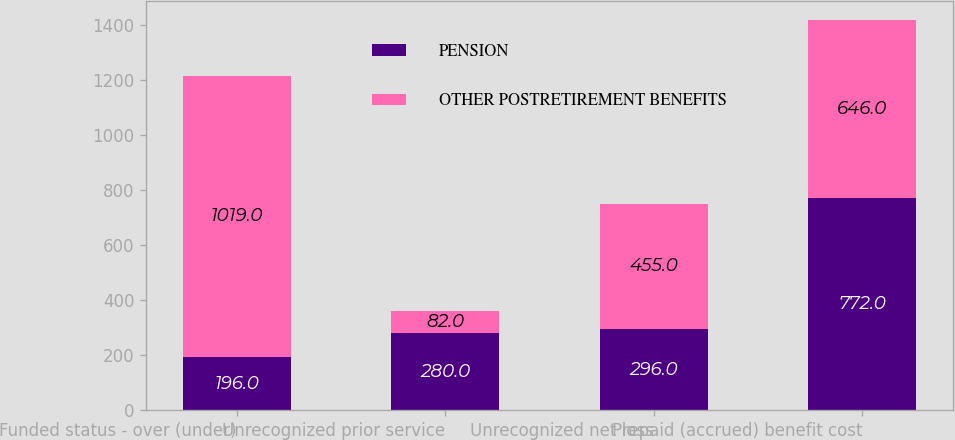Convert chart to OTSL. <chart><loc_0><loc_0><loc_500><loc_500><stacked_bar_chart><ecel><fcel>Funded status - over (under)<fcel>Unrecognized prior service<fcel>Unrecognized net loss<fcel>Prepaid (accrued) benefit cost<nl><fcel>PENSION<fcel>196<fcel>280<fcel>296<fcel>772<nl><fcel>OTHER POSTRETIREMENT BENEFITS<fcel>1019<fcel>82<fcel>455<fcel>646<nl></chart> 